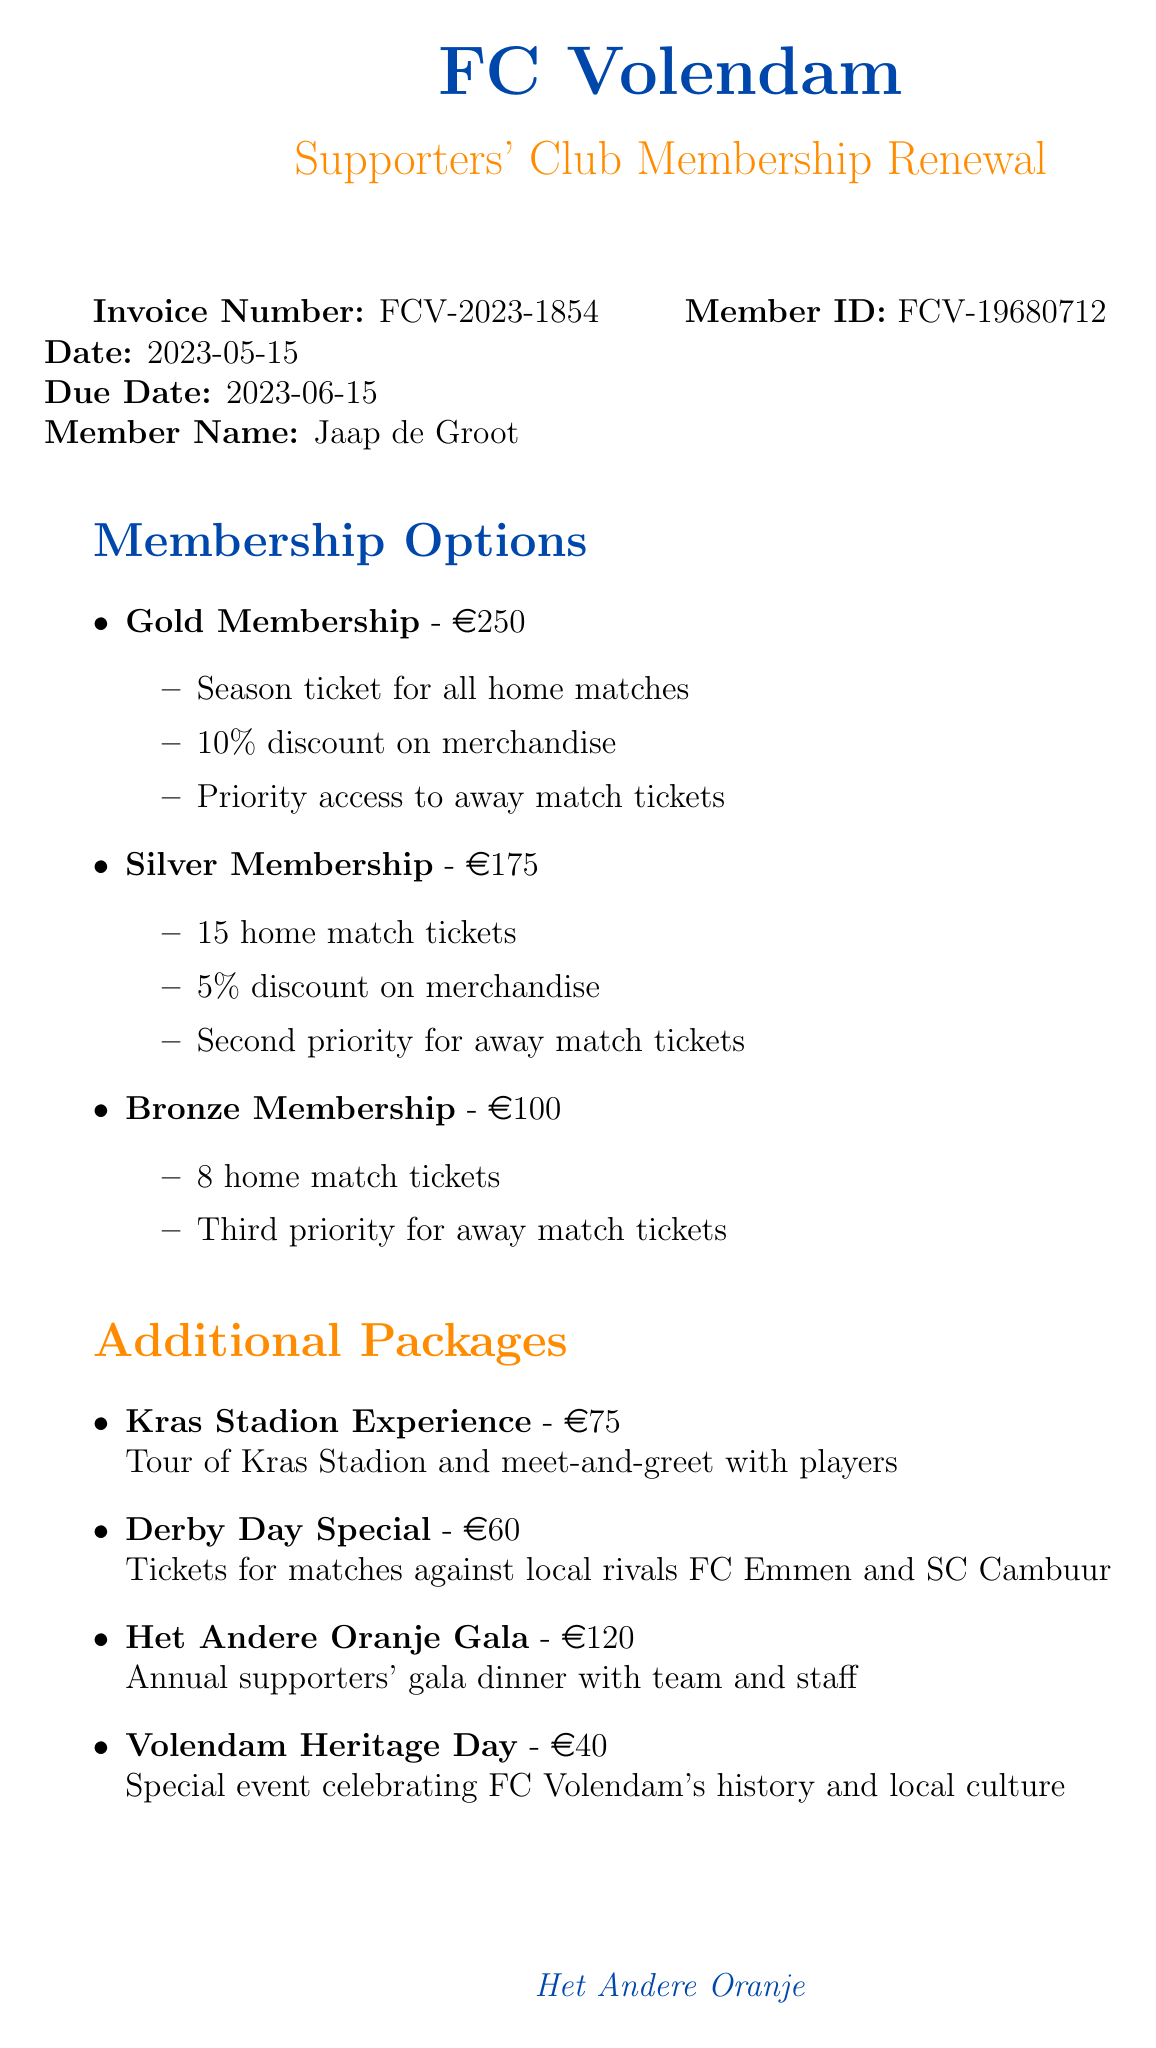What is the invoice number? The invoice number is explicitly stated in the document, which is unique to this particular transaction.
Answer: FCV-2023-1854 Who is the member named in the invoice? The member's name appears prominently in the document's section detailing personal information for this membership renewal.
Answer: Jaap de Groot What is the price of Gold Membership? The price for Gold Membership is clearly indicated next to the membership type in the document.
Answer: 250 How many tickets does Silver Membership include? The number of tickets included in the Silver Membership is listed under its benefits section in the document.
Answer: 15 home match tickets What is the due date for payment? The due date for payment is explicitly mentioned in the invoice, making it clear when action is required.
Answer: 2023-06-15 What is included in the Kras Stadion Experience package? The details of the ticket packages mention what each package entails, including the Kras Stadion Experience.
Answer: Tour of Kras Stadion and meet-and-greet with players How much does the Volendam Heritage Day event cost? The cost of this exclusive event is specified in the document and falls under the additional events section.
Answer: 40 Which payment methods are available? The available payment methods are listed in a distinct section of the invoice, clarifying options for the member.
Answer: iDEAL, Credit Card, Bank Transfer What historical note is included in the document? A specific note about the club's history is provided as an additional contextual detail for members, highlighting the heritage aspect.
Answer: As a local historian, you'll appreciate that your membership helps preserve the legacy of FC Volendam, founded in 1920 and a symbol of our town's rich football heritage 